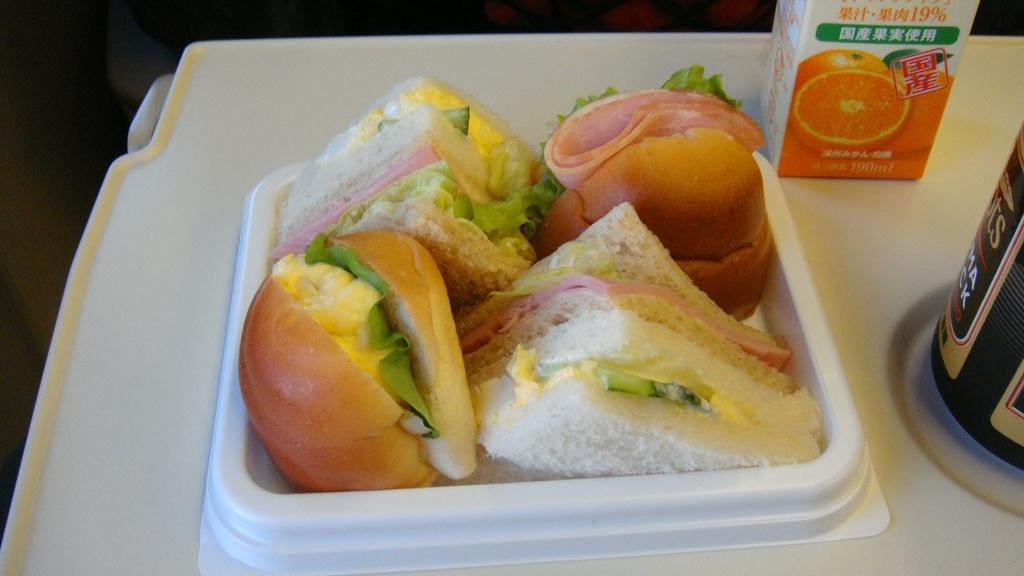What is on the table in the image? There is a food packet and a bottle on the table. What else can be seen on the table besides the food packet and bottle? There is food on the table. What can be observed about the background of the image? The background of the image is dark. What type of trade is being conducted in the image? There is no indication of any trade being conducted in the image; it simply shows a table with a food packet, a bottle, and food. Can you see the brain of the person in the image? There is no person present in the image, so it is not possible to see their brain. 